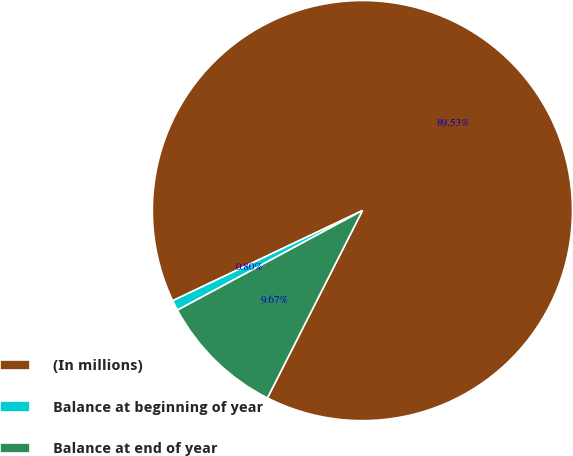<chart> <loc_0><loc_0><loc_500><loc_500><pie_chart><fcel>(In millions)<fcel>Balance at beginning of year<fcel>Balance at end of year<nl><fcel>89.52%<fcel>0.8%<fcel>9.67%<nl></chart> 